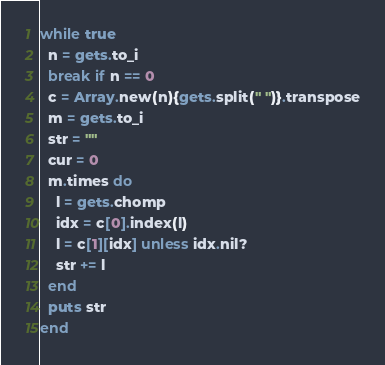<code> <loc_0><loc_0><loc_500><loc_500><_Ruby_>while true
  n = gets.to_i
  break if n == 0
  c = Array.new(n){gets.split(" ")}.transpose
  m = gets.to_i
  str = ""
  cur = 0
  m.times do
    l = gets.chomp
    idx = c[0].index(l)
    l = c[1][idx] unless idx.nil?
    str += l
  end
  puts str
end</code> 